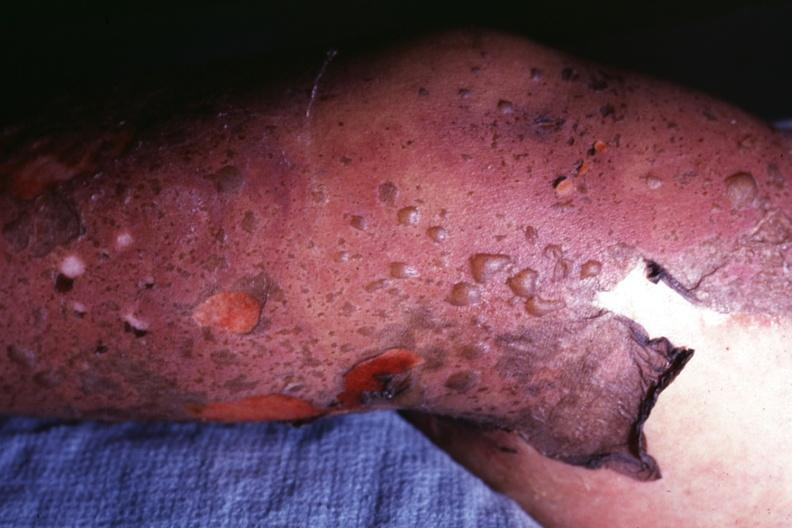where is this?
Answer the question using a single word or phrase. Skin 